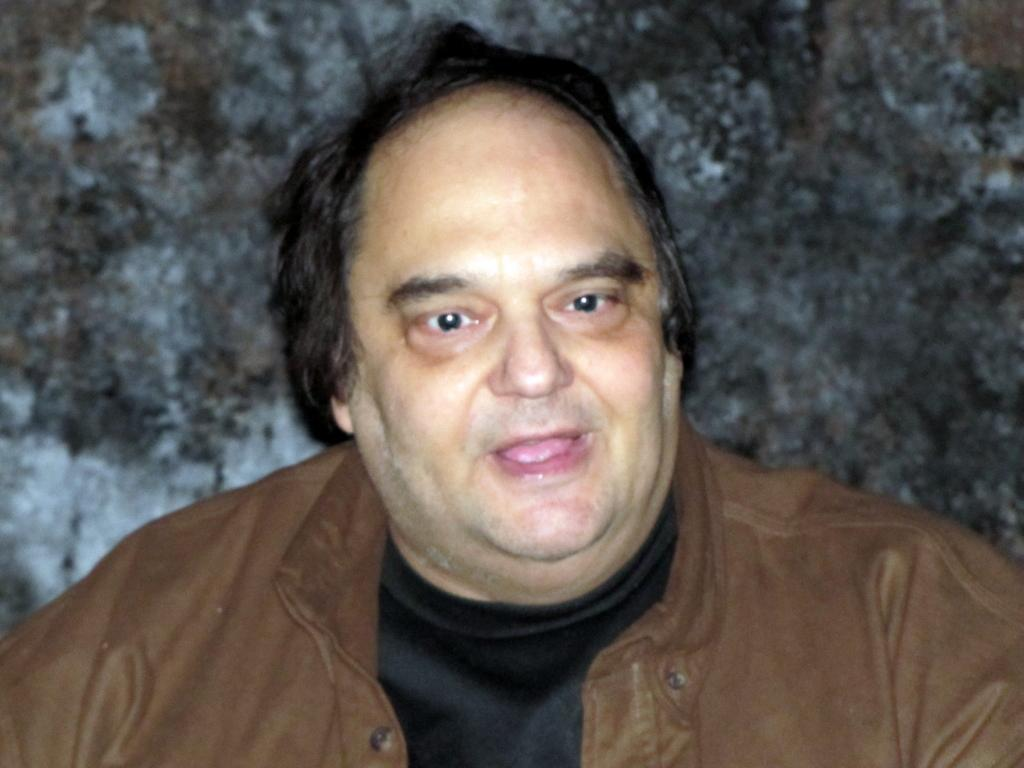Who is the main subject in the image? There is a man in the image. What is the man wearing in the image? The man is wearing a brown color jacket. What can be seen in the background of the image? The background of the image appears to be black. What type of butter is the man using in the image? There is no butter present in the image. How does the man's digestion process appear in the image? There is no indication of the man's digestion process in the image. 